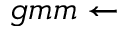<formula> <loc_0><loc_0><loc_500><loc_500>g m m \leftarrow</formula> 